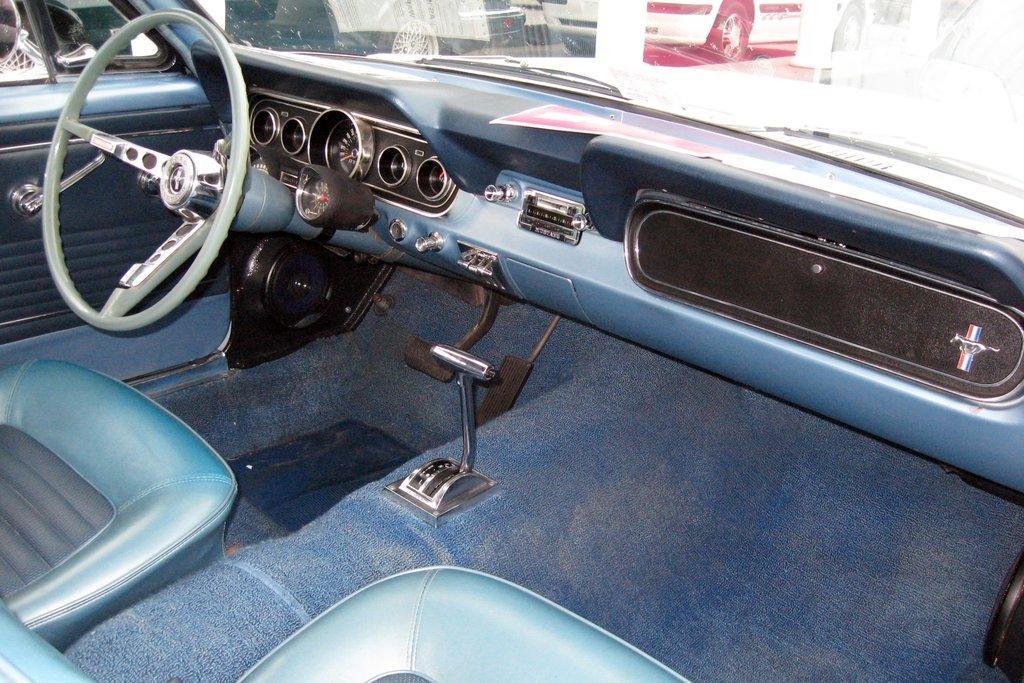Could you give a brief overview of what you see in this image? It is an inside part of a car, on the left side it is the steering. 